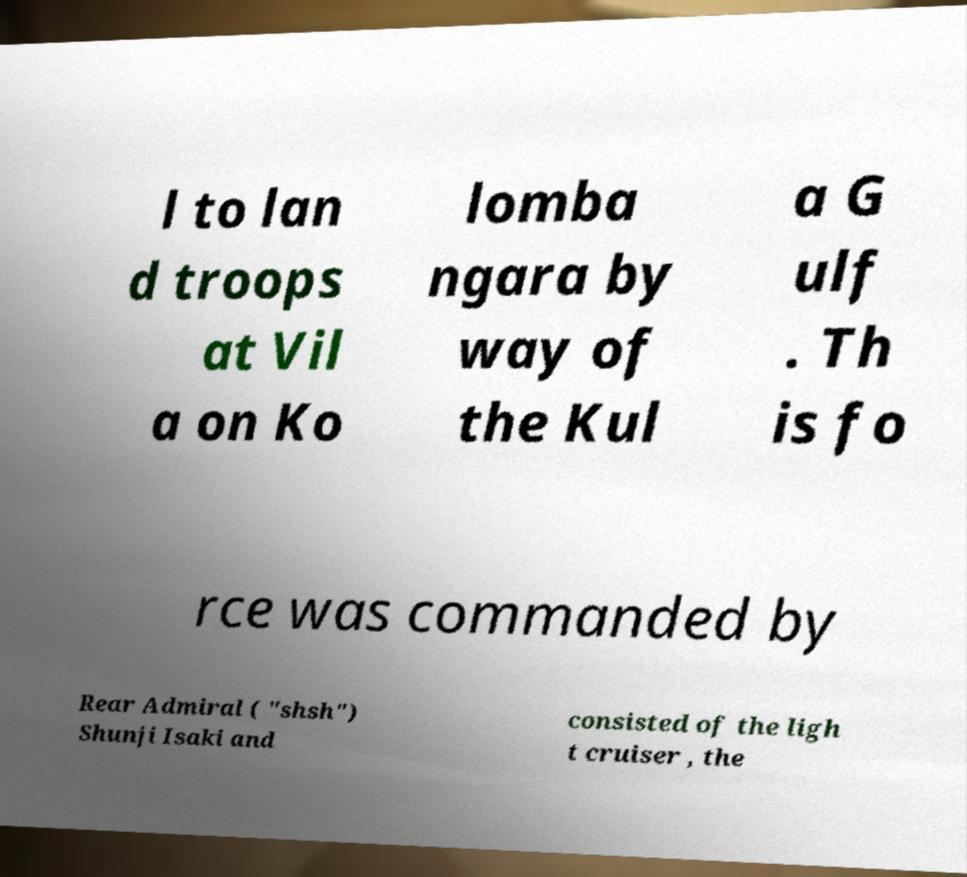I need the written content from this picture converted into text. Can you do that? l to lan d troops at Vil a on Ko lomba ngara by way of the Kul a G ulf . Th is fo rce was commanded by Rear Admiral ( "shsh") Shunji Isaki and consisted of the ligh t cruiser , the 